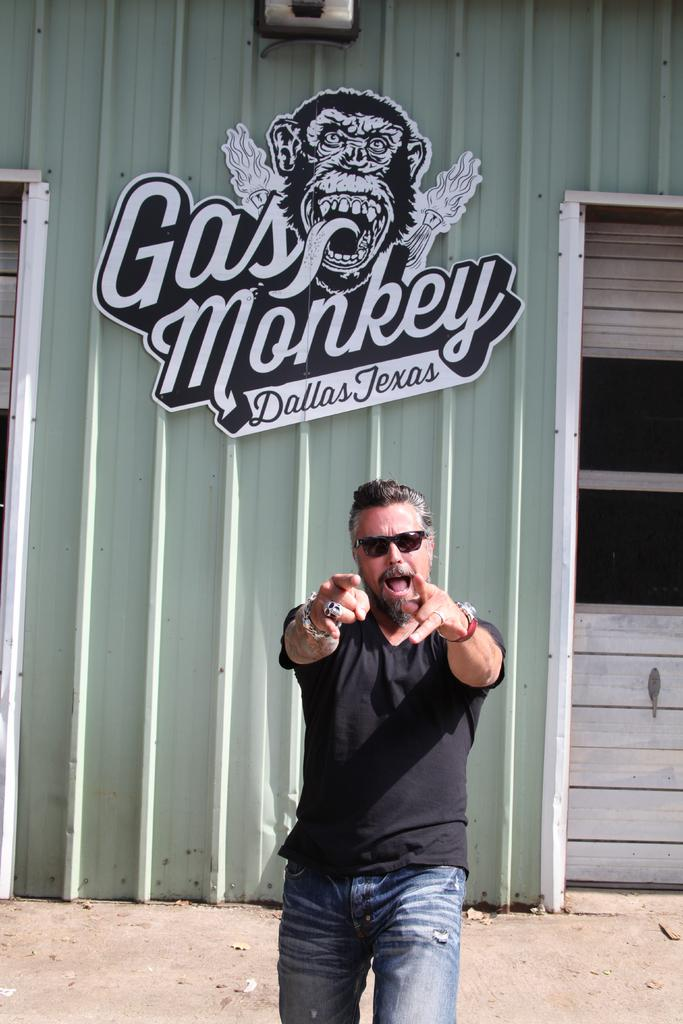Who is present in the image? There is a man in the image. What is the man wearing on his face? The man is wearing goggles. What can be seen in the background of the image? There is a board and a wall in the background of the image. What type of religious ceremony is taking place in the image? There is no indication of a religious ceremony in the image; it features a man wearing goggles with a board and a wall in the background. How many mice are visible in the image? There are no mice present in the image. 